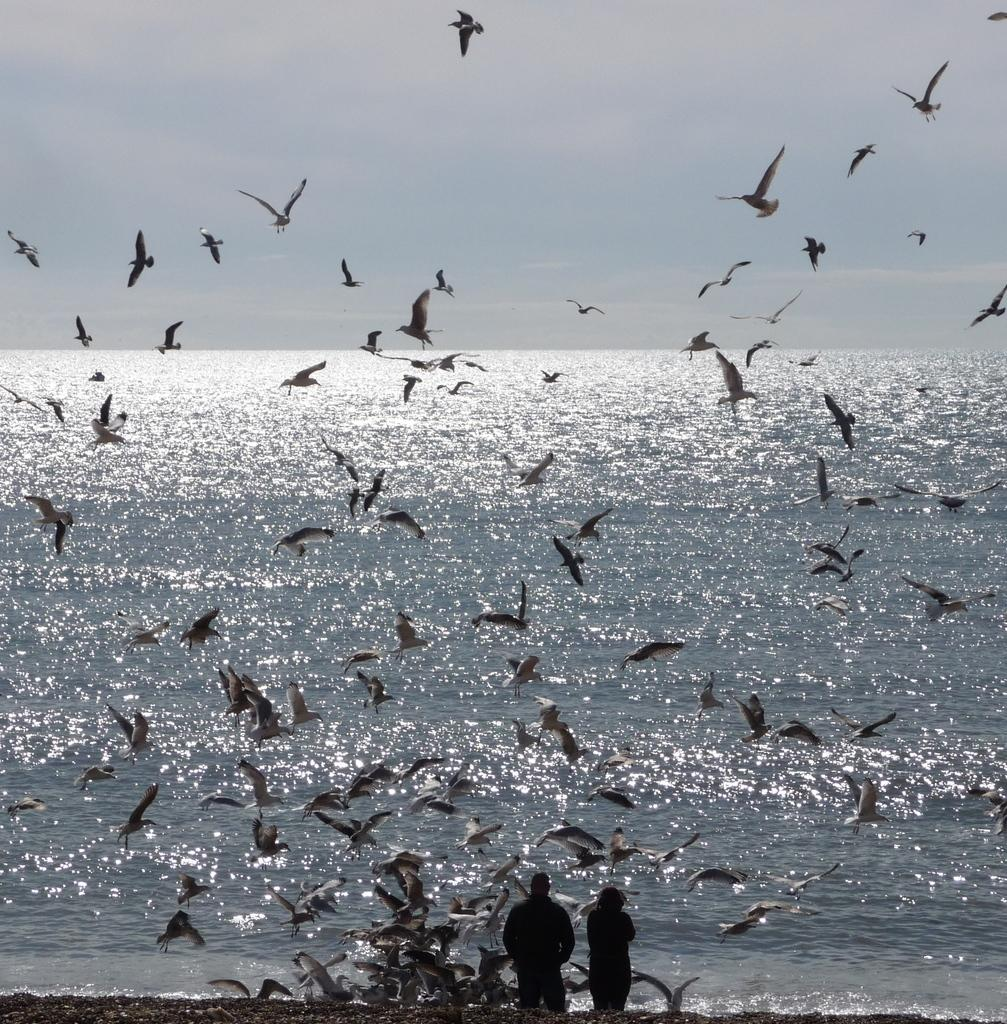How many people are present in the image? There are two persons in the image. What other living creatures can be seen in the image? There are multiple birds in the image. What can be seen in the background of the image? Water and the sky are visible in the background of the image. What type of clover is being eaten by the birds in the image? There is no clover present in the image, and the birds are not shown eating anything. What material is the iron fence surrounding the water in the image? There is no fence, iron or otherwise, visible in the image. 